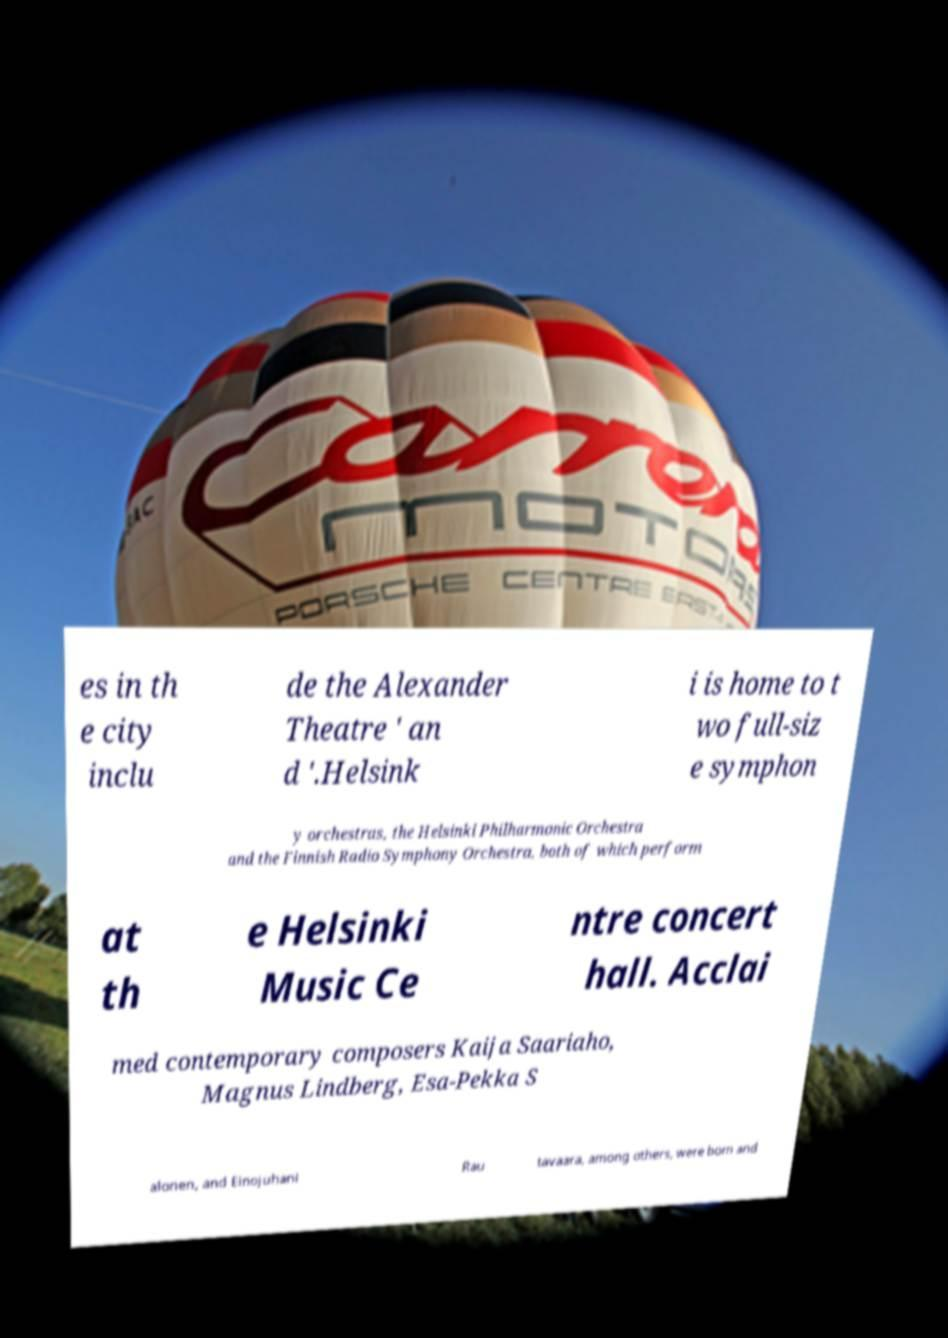Could you extract and type out the text from this image? es in th e city inclu de the Alexander Theatre ' an d '.Helsink i is home to t wo full-siz e symphon y orchestras, the Helsinki Philharmonic Orchestra and the Finnish Radio Symphony Orchestra, both of which perform at th e Helsinki Music Ce ntre concert hall. Acclai med contemporary composers Kaija Saariaho, Magnus Lindberg, Esa-Pekka S alonen, and Einojuhani Rau tavaara, among others, were born and 